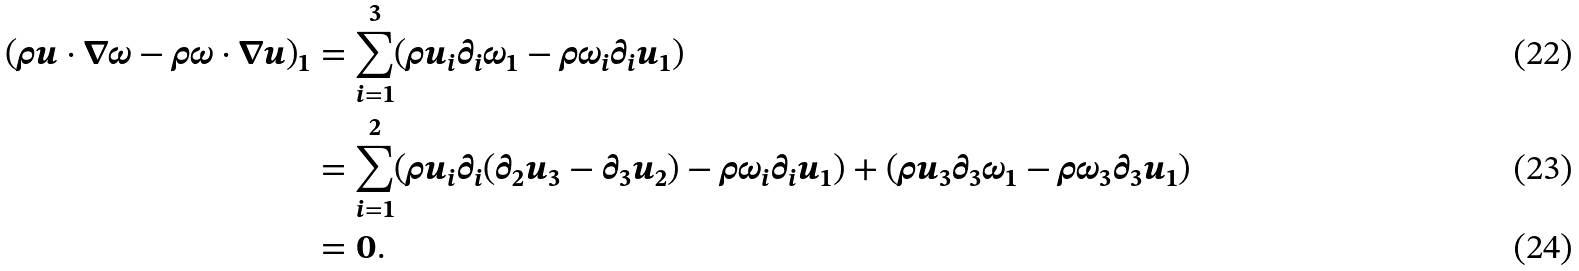<formula> <loc_0><loc_0><loc_500><loc_500>( \rho u \cdot \nabla \omega - \rho \omega \cdot \nabla u ) _ { 1 } & = \sum _ { i = 1 } ^ { 3 } ( \rho u _ { i } \partial _ { i } \omega _ { 1 } - \rho \omega _ { i } \partial _ { i } u _ { 1 } ) \\ & = \sum _ { i = 1 } ^ { 2 } ( \rho u _ { i } \partial _ { i } ( \partial _ { 2 } u _ { 3 } - \partial _ { 3 } u _ { 2 } ) - \rho \omega _ { i } \partial _ { i } u _ { 1 } ) + ( \rho u _ { 3 } \partial _ { 3 } \omega _ { 1 } - \rho \omega _ { 3 } \partial _ { 3 } u _ { 1 } ) \\ & = 0 .</formula> 